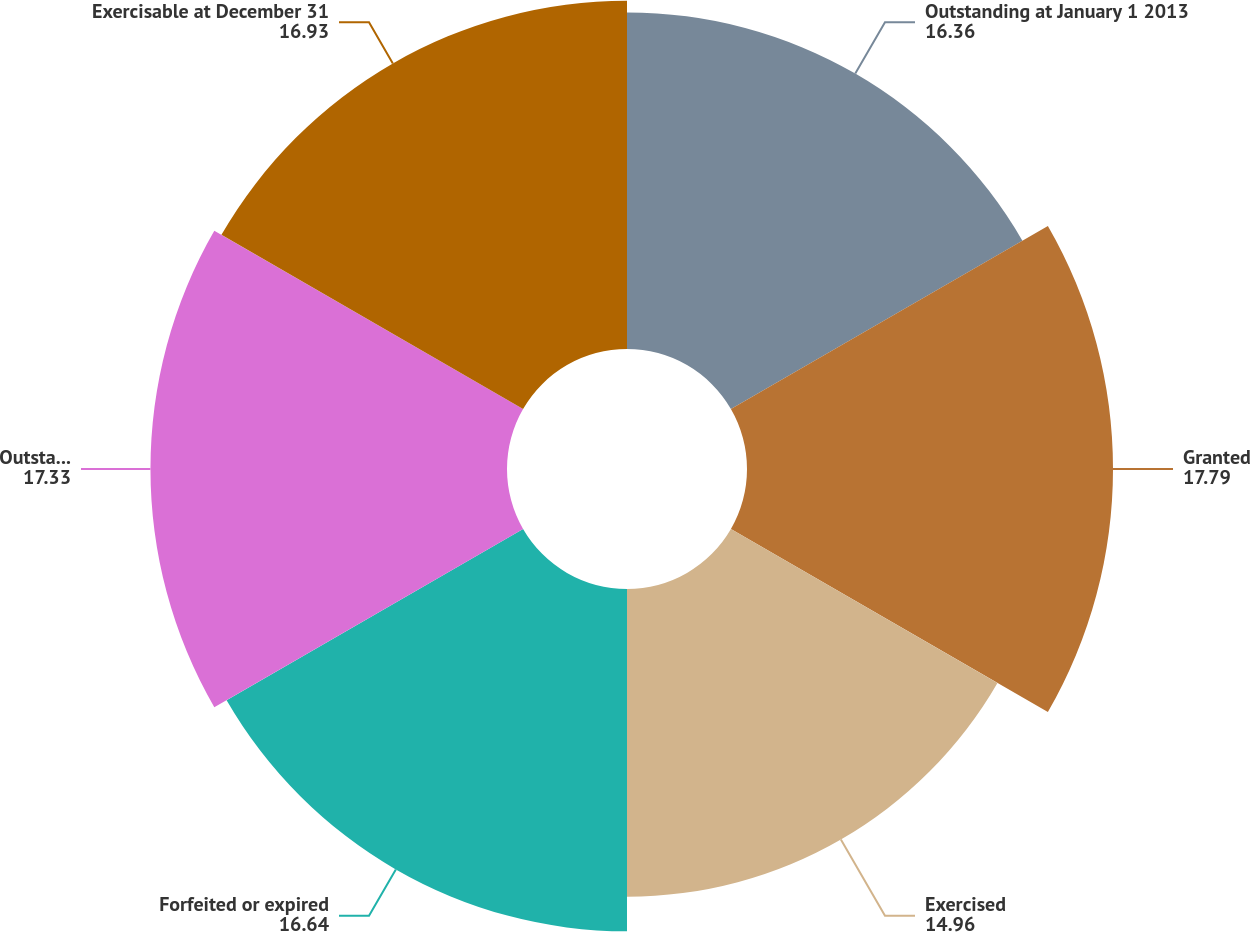Convert chart. <chart><loc_0><loc_0><loc_500><loc_500><pie_chart><fcel>Outstanding at January 1 2013<fcel>Granted<fcel>Exercised<fcel>Forfeited or expired<fcel>Outstanding at December 31<fcel>Exercisable at December 31<nl><fcel>16.36%<fcel>17.79%<fcel>14.96%<fcel>16.64%<fcel>17.33%<fcel>16.93%<nl></chart> 